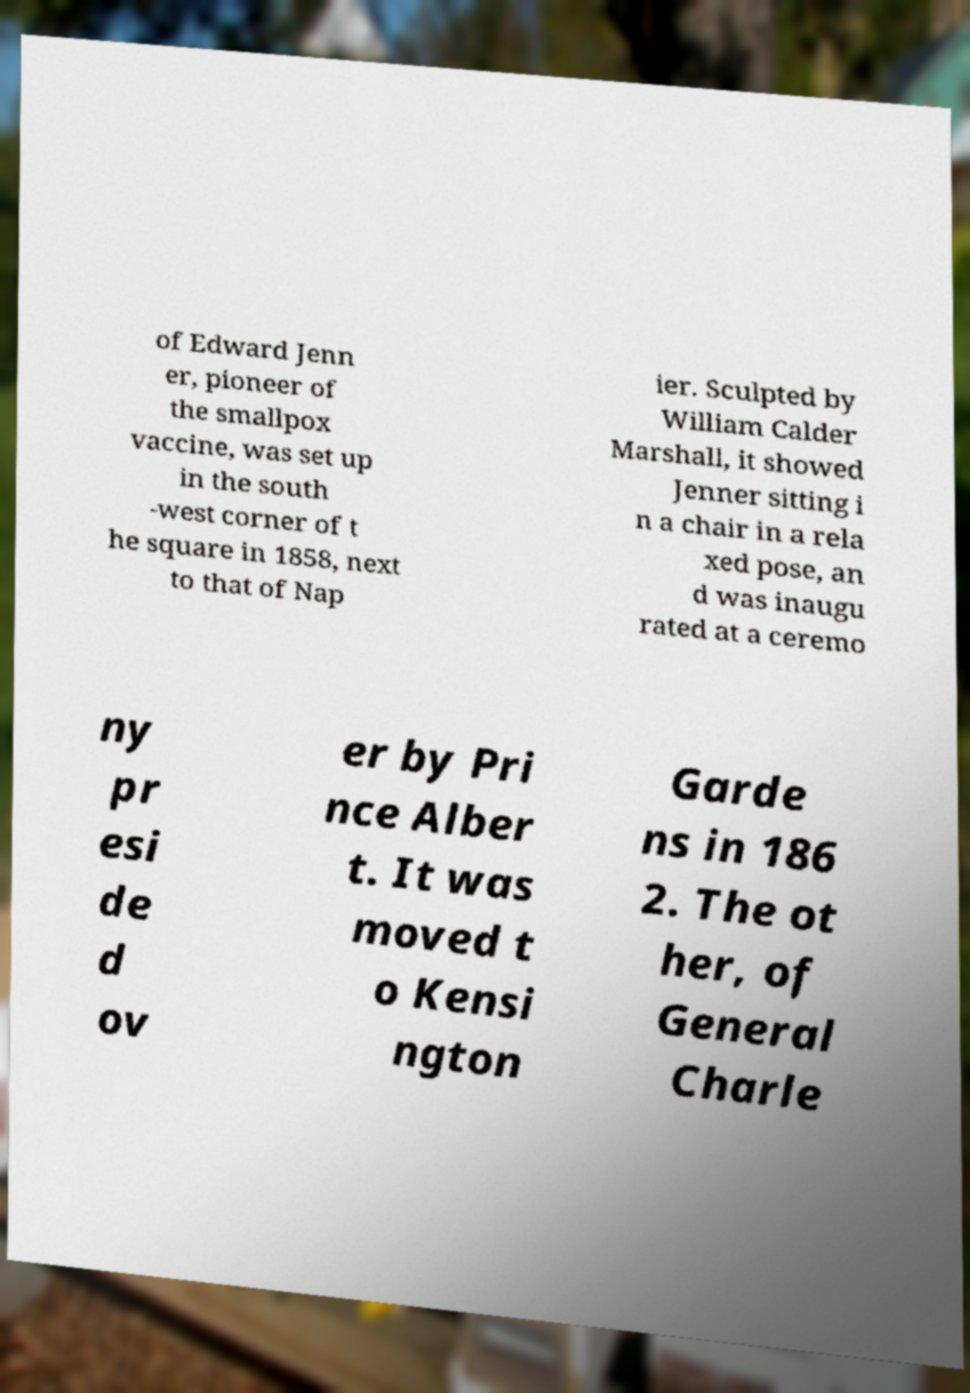Can you read and provide the text displayed in the image?This photo seems to have some interesting text. Can you extract and type it out for me? of Edward Jenn er, pioneer of the smallpox vaccine, was set up in the south -west corner of t he square in 1858, next to that of Nap ier. Sculpted by William Calder Marshall, it showed Jenner sitting i n a chair in a rela xed pose, an d was inaugu rated at a ceremo ny pr esi de d ov er by Pri nce Alber t. It was moved t o Kensi ngton Garde ns in 186 2. The ot her, of General Charle 